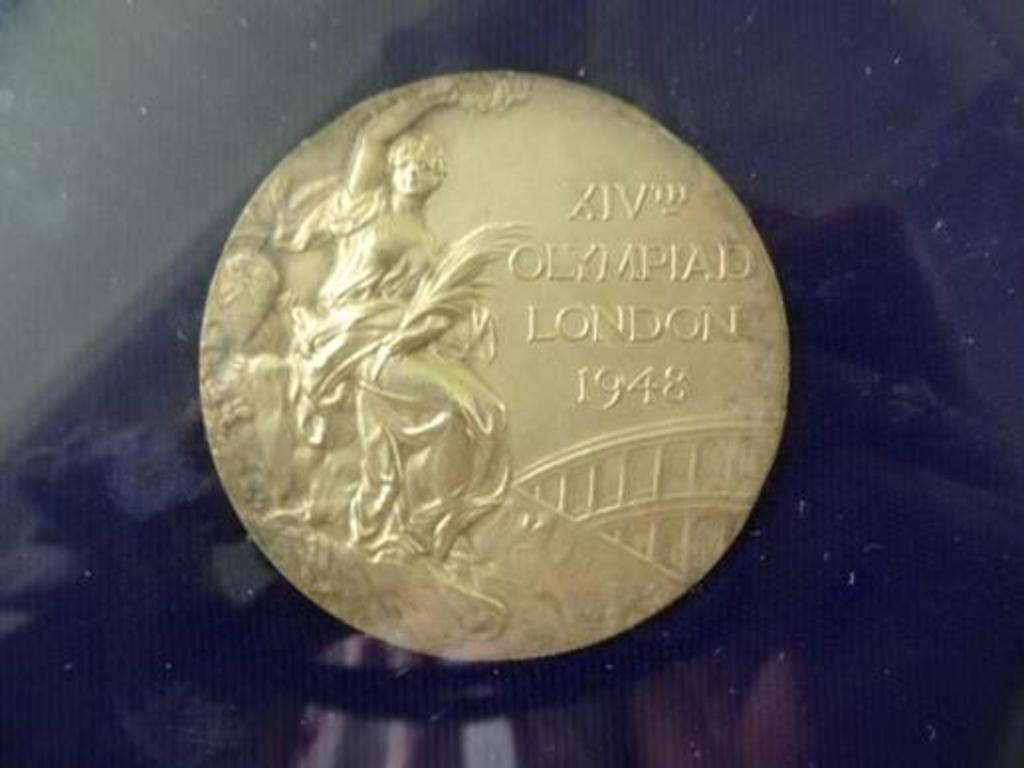Provide a one-sentence caption for the provided image. A coin with Olympiad London 1948 engraved on it. 